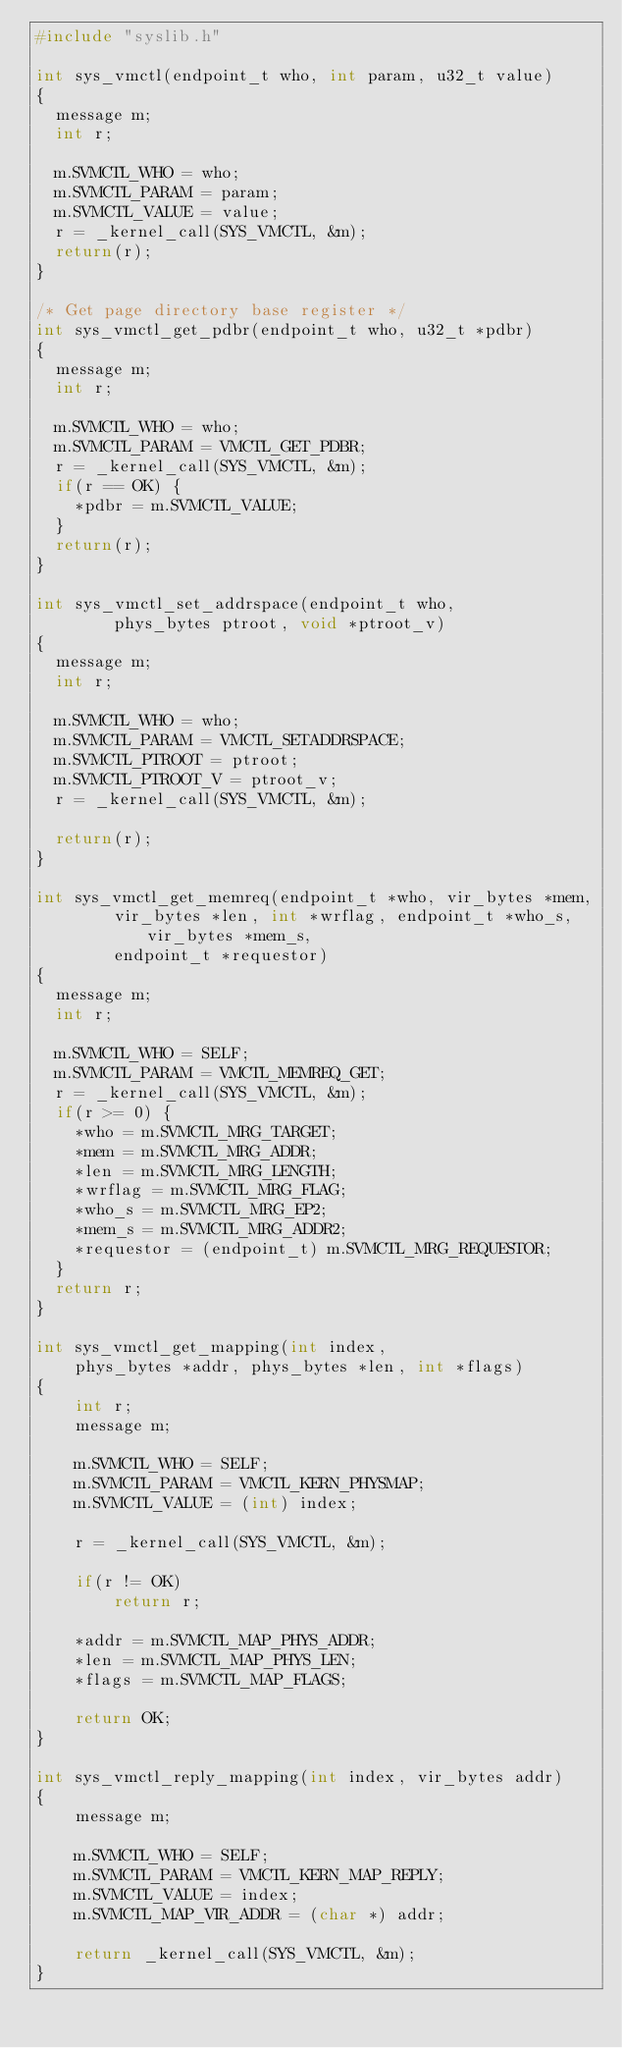<code> <loc_0><loc_0><loc_500><loc_500><_C_>#include "syslib.h"

int sys_vmctl(endpoint_t who, int param, u32_t value)
{
  message m;
  int r;

  m.SVMCTL_WHO = who;
  m.SVMCTL_PARAM = param;
  m.SVMCTL_VALUE = value;
  r = _kernel_call(SYS_VMCTL, &m);
  return(r);
}

/* Get page directory base register */
int sys_vmctl_get_pdbr(endpoint_t who, u32_t *pdbr)
{
  message m;
  int r;

  m.SVMCTL_WHO = who;
  m.SVMCTL_PARAM = VMCTL_GET_PDBR;
  r = _kernel_call(SYS_VMCTL, &m);
  if(r == OK) {
	*pdbr = m.SVMCTL_VALUE;
  }
  return(r);
}

int sys_vmctl_set_addrspace(endpoint_t who,
        phys_bytes ptroot, void *ptroot_v)
{
  message m;
  int r;

  m.SVMCTL_WHO = who;
  m.SVMCTL_PARAM = VMCTL_SETADDRSPACE;
  m.SVMCTL_PTROOT = ptroot;
  m.SVMCTL_PTROOT_V = ptroot_v;
  r = _kernel_call(SYS_VMCTL, &m);

  return(r);
}

int sys_vmctl_get_memreq(endpoint_t *who, vir_bytes *mem,
        vir_bytes *len, int *wrflag, endpoint_t *who_s, vir_bytes *mem_s,
        endpoint_t *requestor)
{
  message m;
  int r;

  m.SVMCTL_WHO = SELF;
  m.SVMCTL_PARAM = VMCTL_MEMREQ_GET;
  r = _kernel_call(SYS_VMCTL, &m);
  if(r >= 0) {
	*who = m.SVMCTL_MRG_TARGET;
	*mem = m.SVMCTL_MRG_ADDR;
	*len = m.SVMCTL_MRG_LENGTH;
	*wrflag = m.SVMCTL_MRG_FLAG;
	*who_s = m.SVMCTL_MRG_EP2;
	*mem_s = m.SVMCTL_MRG_ADDR2;
	*requestor = (endpoint_t) m.SVMCTL_MRG_REQUESTOR;
  }
  return r;
}

int sys_vmctl_get_mapping(int index,
	phys_bytes *addr, phys_bytes *len, int *flags)
{
	int r;
	message m;

	m.SVMCTL_WHO = SELF;
	m.SVMCTL_PARAM = VMCTL_KERN_PHYSMAP;
	m.SVMCTL_VALUE = (int) index;

	r = _kernel_call(SYS_VMCTL, &m);

	if(r != OK)
		return r;

	*addr = m.SVMCTL_MAP_PHYS_ADDR;
	*len = m.SVMCTL_MAP_PHYS_LEN;
	*flags = m.SVMCTL_MAP_FLAGS;

	return OK;
}

int sys_vmctl_reply_mapping(int index, vir_bytes addr)
{
	message m;

	m.SVMCTL_WHO = SELF;
	m.SVMCTL_PARAM = VMCTL_KERN_MAP_REPLY;
	m.SVMCTL_VALUE = index;
	m.SVMCTL_MAP_VIR_ADDR = (char *) addr;

	return _kernel_call(SYS_VMCTL, &m);
}
</code> 